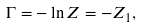Convert formula to latex. <formula><loc_0><loc_0><loc_500><loc_500>\Gamma = - \ln Z = - Z _ { 1 } ,</formula> 